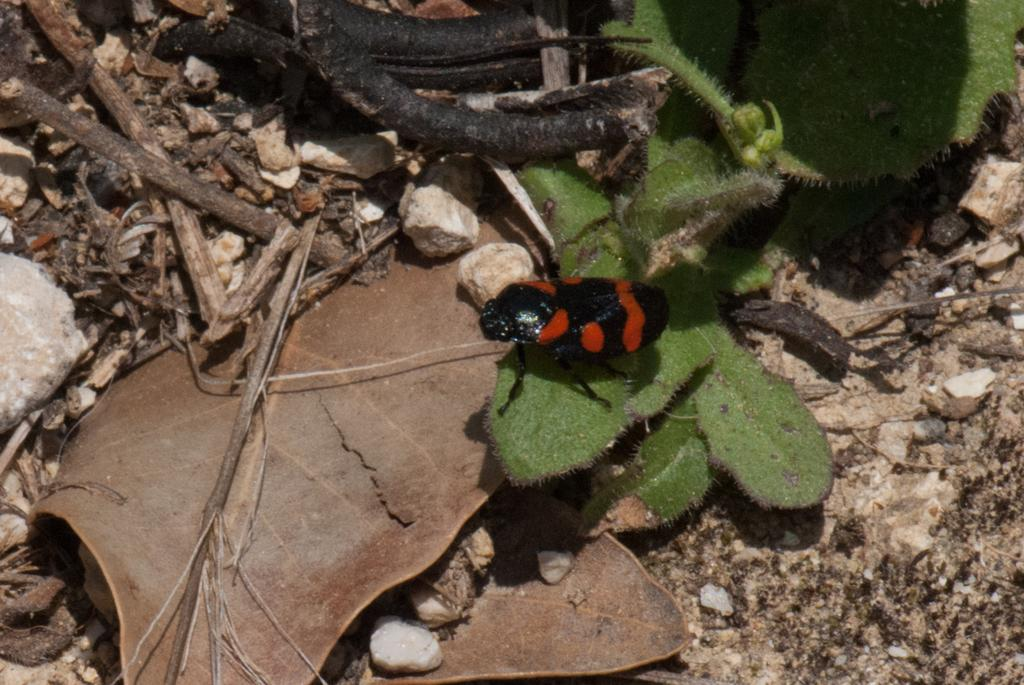What type of creature can be seen in the image? There is an insect in the image. What colors are present on the insect? The insect is black and orange in color. Where is the insect located in the image? The insect is on green leaves. What can be seen on the left side of the image? There are dried leaves on the left side of the image. How does the wind affect the insect's ability to answer questions in the image? There is no indication of wind in the image, and insects do not have the ability to answer questions. 